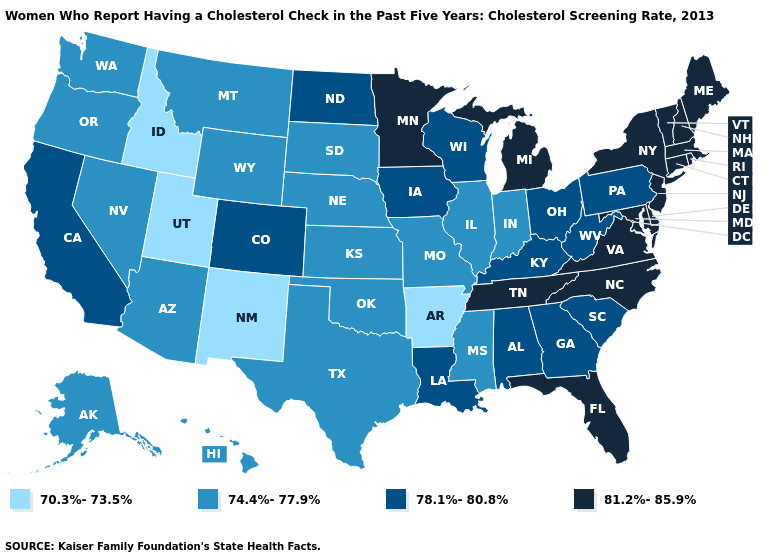Among the states that border Arizona , which have the highest value?
Answer briefly. California, Colorado. Does Arizona have the highest value in the USA?
Short answer required. No. Name the states that have a value in the range 78.1%-80.8%?
Keep it brief. Alabama, California, Colorado, Georgia, Iowa, Kentucky, Louisiana, North Dakota, Ohio, Pennsylvania, South Carolina, West Virginia, Wisconsin. What is the lowest value in the USA?
Give a very brief answer. 70.3%-73.5%. Name the states that have a value in the range 78.1%-80.8%?
Keep it brief. Alabama, California, Colorado, Georgia, Iowa, Kentucky, Louisiana, North Dakota, Ohio, Pennsylvania, South Carolina, West Virginia, Wisconsin. What is the lowest value in the USA?
Answer briefly. 70.3%-73.5%. Which states have the lowest value in the MidWest?
Short answer required. Illinois, Indiana, Kansas, Missouri, Nebraska, South Dakota. What is the highest value in the Northeast ?
Quick response, please. 81.2%-85.9%. Among the states that border Arkansas , which have the lowest value?
Keep it brief. Mississippi, Missouri, Oklahoma, Texas. Among the states that border Washington , does Oregon have the highest value?
Concise answer only. Yes. Name the states that have a value in the range 81.2%-85.9%?
Quick response, please. Connecticut, Delaware, Florida, Maine, Maryland, Massachusetts, Michigan, Minnesota, New Hampshire, New Jersey, New York, North Carolina, Rhode Island, Tennessee, Vermont, Virginia. What is the lowest value in the Northeast?
Keep it brief. 78.1%-80.8%. Name the states that have a value in the range 81.2%-85.9%?
Be succinct. Connecticut, Delaware, Florida, Maine, Maryland, Massachusetts, Michigan, Minnesota, New Hampshire, New Jersey, New York, North Carolina, Rhode Island, Tennessee, Vermont, Virginia. What is the value of Pennsylvania?
Concise answer only. 78.1%-80.8%. What is the value of South Carolina?
Answer briefly. 78.1%-80.8%. 